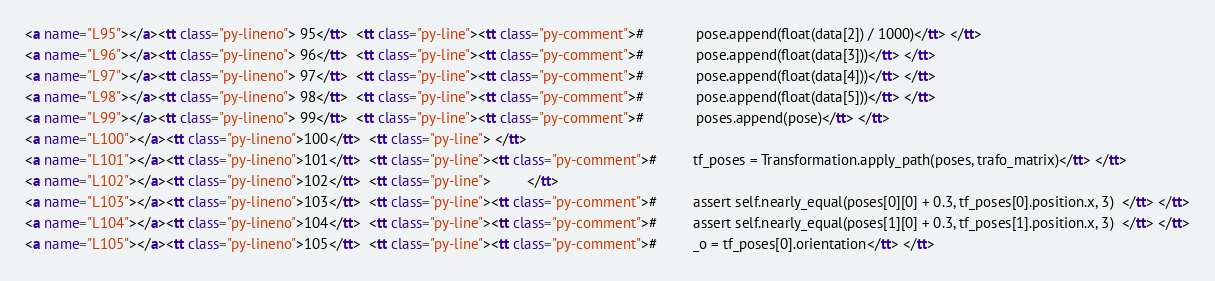<code> <loc_0><loc_0><loc_500><loc_500><_HTML_><a name="L95"></a><tt class="py-lineno"> 95</tt>  <tt class="py-line"><tt class="py-comment">#             pose.append(float(data[2]) / 1000)</tt> </tt>
<a name="L96"></a><tt class="py-lineno"> 96</tt>  <tt class="py-line"><tt class="py-comment">#             pose.append(float(data[3]))</tt> </tt>
<a name="L97"></a><tt class="py-lineno"> 97</tt>  <tt class="py-line"><tt class="py-comment">#             pose.append(float(data[4]))</tt> </tt>
<a name="L98"></a><tt class="py-lineno"> 98</tt>  <tt class="py-line"><tt class="py-comment">#             pose.append(float(data[5]))</tt> </tt>
<a name="L99"></a><tt class="py-lineno"> 99</tt>  <tt class="py-line"><tt class="py-comment">#             poses.append(pose)</tt> </tt>
<a name="L100"></a><tt class="py-lineno">100</tt>  <tt class="py-line"> </tt>
<a name="L101"></a><tt class="py-lineno">101</tt>  <tt class="py-line"><tt class="py-comment">#         tf_poses = Transformation.apply_path(poses, trafo_matrix)</tt> </tt>
<a name="L102"></a><tt class="py-lineno">102</tt>  <tt class="py-line">         </tt>
<a name="L103"></a><tt class="py-lineno">103</tt>  <tt class="py-line"><tt class="py-comment">#         assert self.nearly_equal(poses[0][0] + 0.3, tf_poses[0].position.x, 3)  </tt> </tt>
<a name="L104"></a><tt class="py-lineno">104</tt>  <tt class="py-line"><tt class="py-comment">#         assert self.nearly_equal(poses[1][0] + 0.3, tf_poses[1].position.x, 3)  </tt> </tt>
<a name="L105"></a><tt class="py-lineno">105</tt>  <tt class="py-line"><tt class="py-comment">#         _o = tf_poses[0].orientation</tt> </tt></code> 